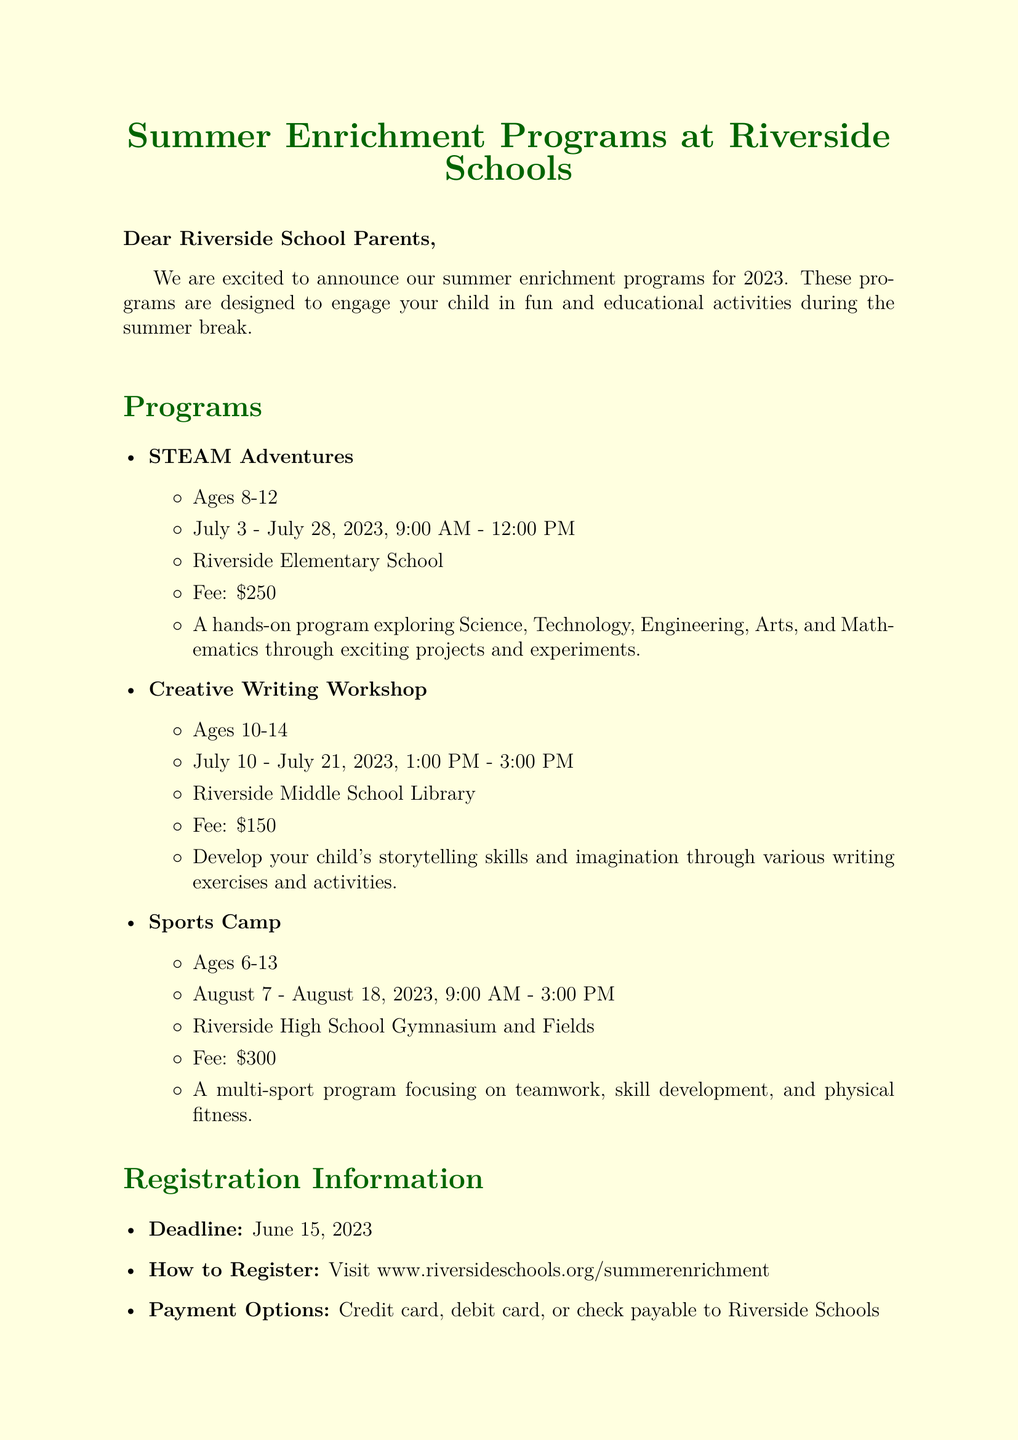What is the deadline for registration? The deadline is stated in the registration information section of the document.
Answer: June 15, 2023 What is the fee for the Sports Camp? The fee for the Sports Camp is mentioned in the program description.
Answer: $300 Where will the Creative Writing Workshop take place? The location for the Creative Writing Workshop is detailed in the program descriptions.
Answer: Riverside Middle School Library What age group is the STEAM Adventures program for? The age group is specified in the description of the STEAM Adventures program.
Answer: Ages 8-12 What options are available for payment? Payment options are listed under the registration information section.
Answer: Credit card, debit card, or check payable to Riverside Schools Which program runs in August? This asks for a specific program mentioned in the document's programs section.
Answer: Sports Camp Is there a discount available for siblings? The additional information mentions any discounts available for families registering multiple children.
Answer: 10% sibling discount available Who is the contact person for the summer programs? The contact section specifies the coordinator for these programs.
Answer: Mrs. Sarah Thompson What is the time for the STEAM Adventures program? The time is included in the program details for STEAM Adventures.
Answer: 9:00 AM - 12:00 PM 